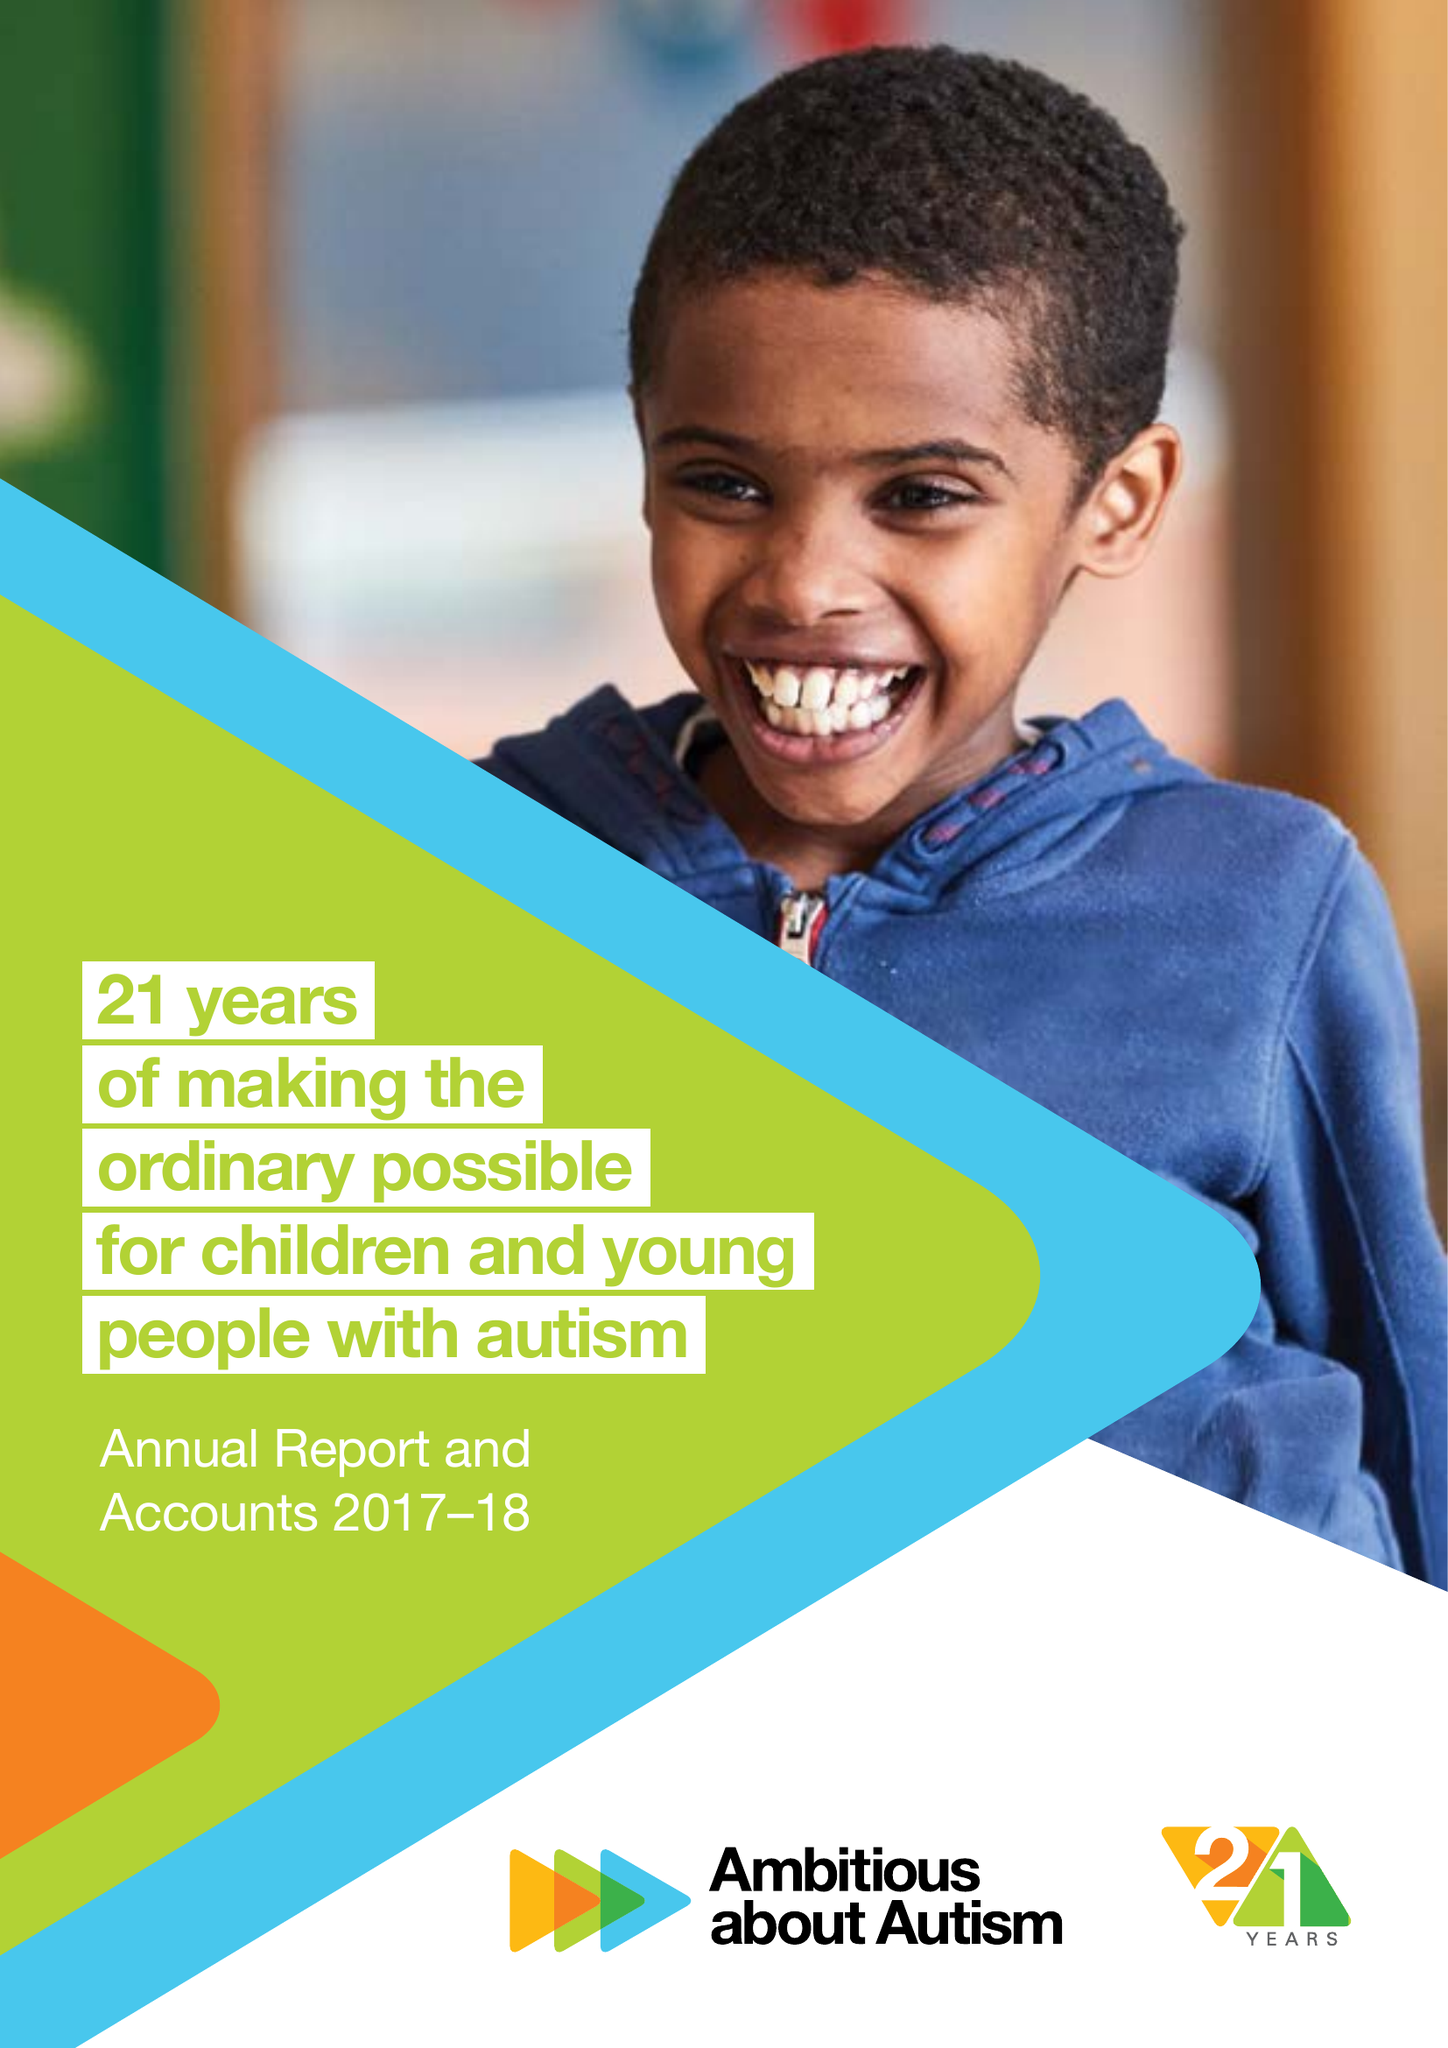What is the value for the address__post_town?
Answer the question using a single word or phrase. LONDON 